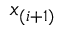Convert formula to latex. <formula><loc_0><loc_0><loc_500><loc_500>x _ { ( i + 1 ) }</formula> 